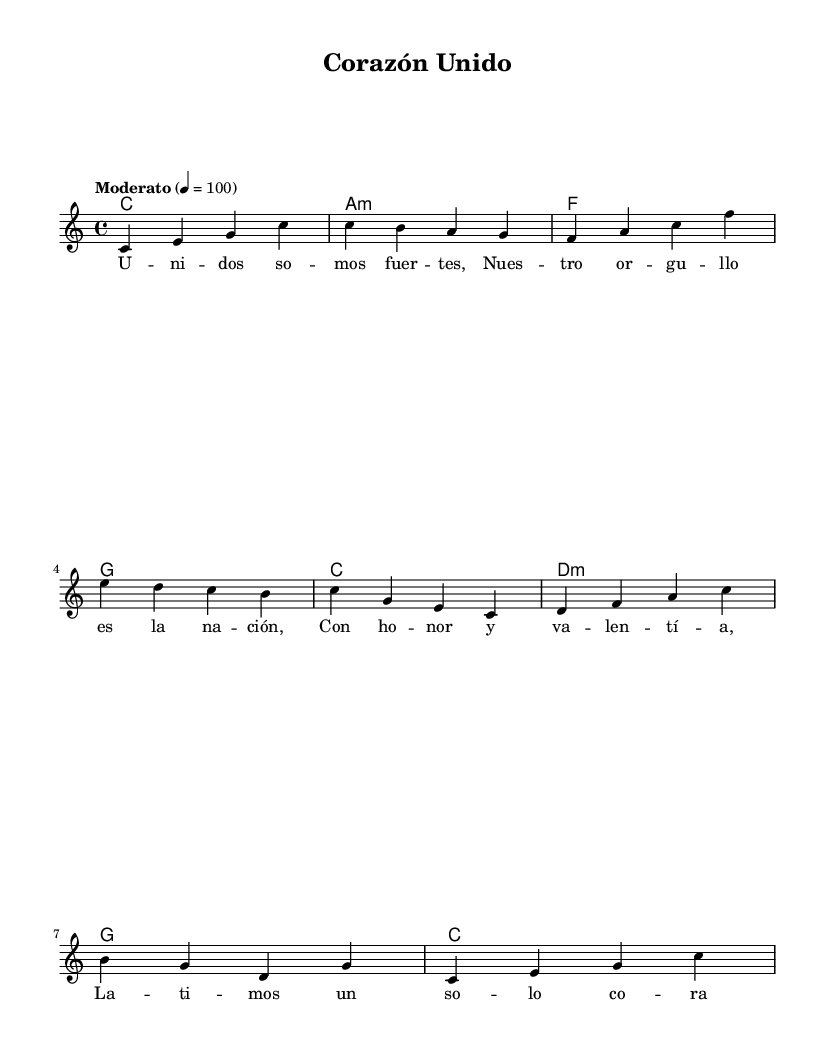What is the key signature of this music? The key signature is C major, which has no sharps or flats.
Answer: C major What is the time signature of this piece? The time signature is indicated as 4/4, meaning there are four beats per measure.
Answer: 4/4 What is the tempo marking of the piece? The tempo marking indicates "Moderato" at a speed of 100 beats per minute.
Answer: Moderato How many measures are there in the melody section? The melody consists of eight measures as counted from the beginning to the end in the music.
Answer: Eight What is the first chord in the harmony section? The first chord indicated in the harmony section is C major, which is the starting point for this piece.
Answer: C Which word in the lyrics translates to "nation" in English? The word "nación" in the lyrics translates directly to "nation" in English.
Answer: nación Describe the overall theme of the lyrics. The overall theme expresses unity and national pride among the people of Latin America, highlighting a shared identity.
Answer: Unity and pride 